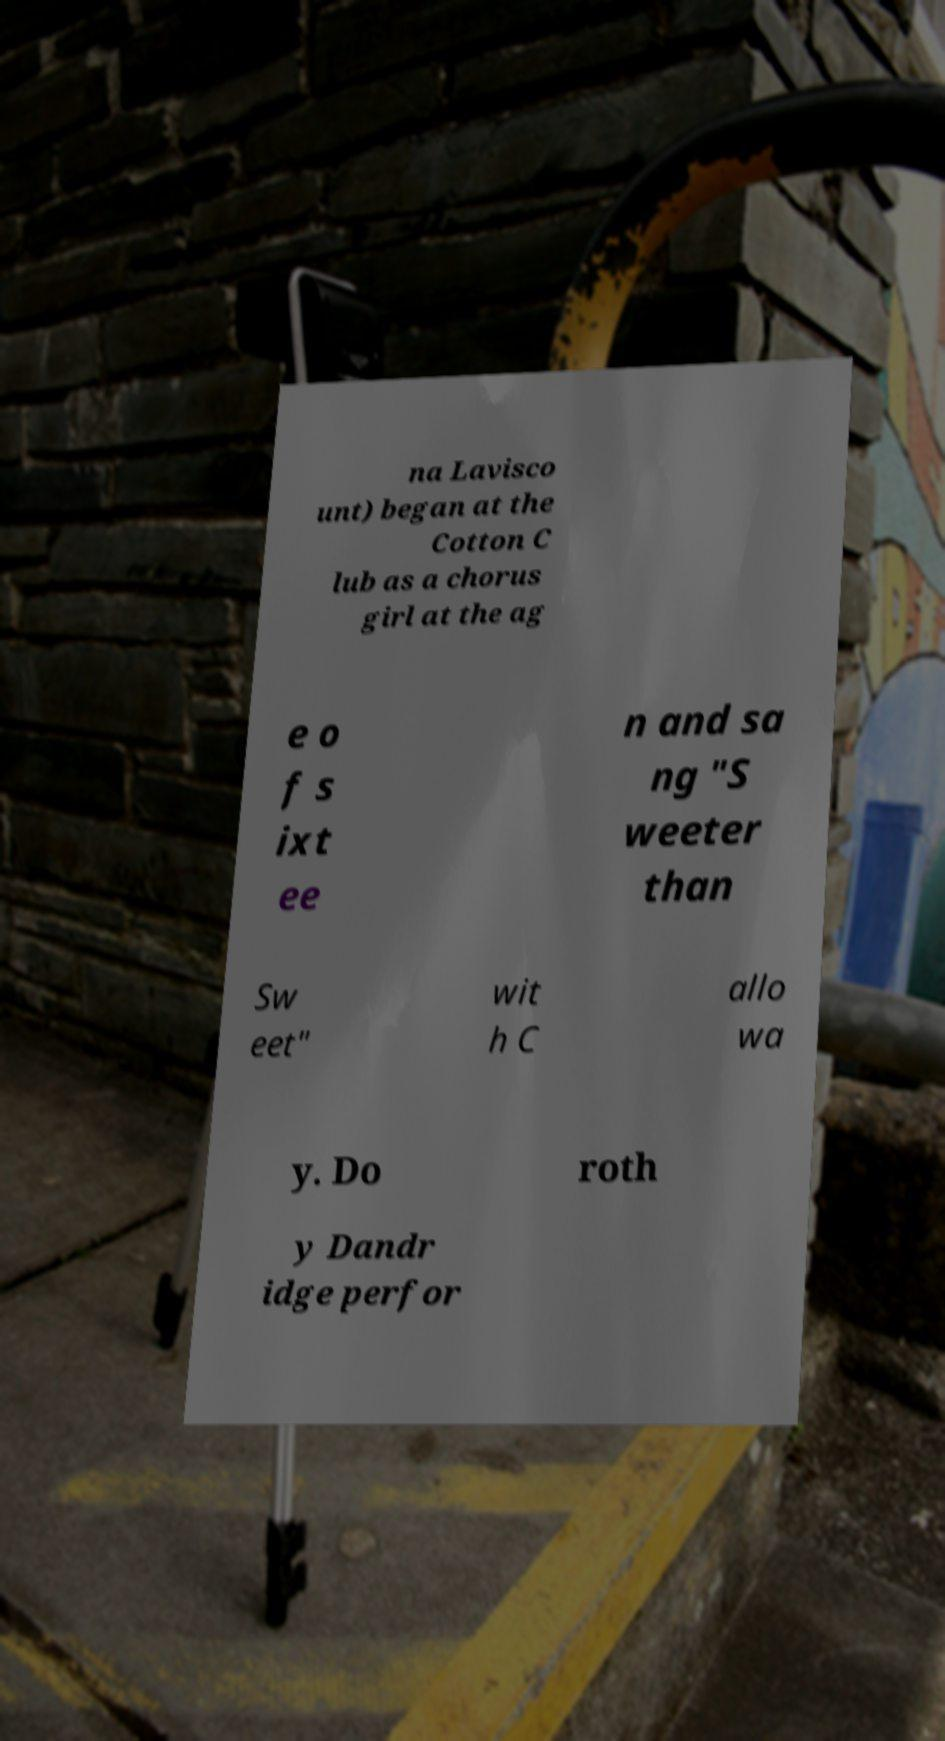What messages or text are displayed in this image? I need them in a readable, typed format. na Lavisco unt) began at the Cotton C lub as a chorus girl at the ag e o f s ixt ee n and sa ng "S weeter than Sw eet" wit h C allo wa y. Do roth y Dandr idge perfor 